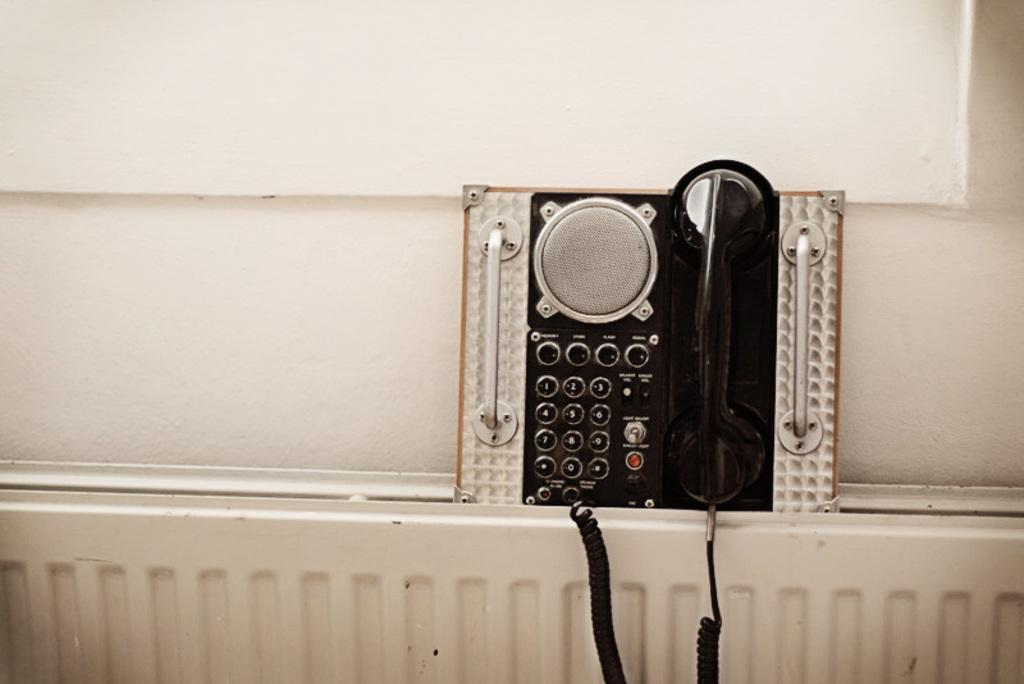What object is the main focus of the image? The main focus of the image is a telephone. What can be seen in the background of the image? There is a wall in the background of the image. What type of shade does the telephone provide in the image? The telephone does not provide any shade in the image, as it is an inanimate object and cannot cast a shadow. 